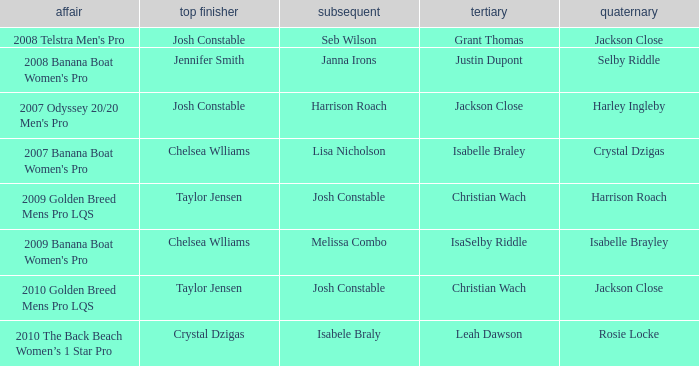Who was Fourth in the 2008 Telstra Men's Pro Event? Jackson Close. 